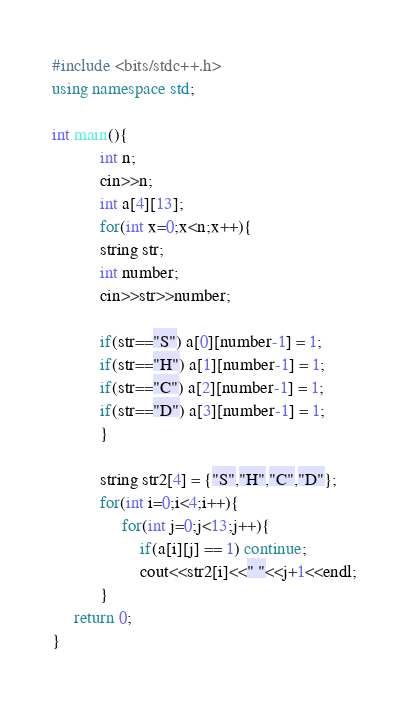<code> <loc_0><loc_0><loc_500><loc_500><_C++_>#include <bits/stdc++.h>
using namespace std;

int main(){
           int n;
           cin>>n;
           int a[4][13];
           for(int x=0;x<n;x++){
           string str;
           int number;
           cin>>str>>number;
    
           if(str=="S") a[0][number-1] = 1;
           if(str=="H") a[1][number-1] = 1;
           if(str=="C") a[2][number-1] = 1;
           if(str=="D") a[3][number-1] = 1;
           }
        
           string str2[4] = {"S","H","C","D"};
           for(int i=0;i<4;i++){
                for(int j=0;j<13;j++){
                    if(a[i][j] == 1) continue;
                    cout<<str2[i]<<" "<<j+1<<endl;
           }
     return 0;
}
</code> 